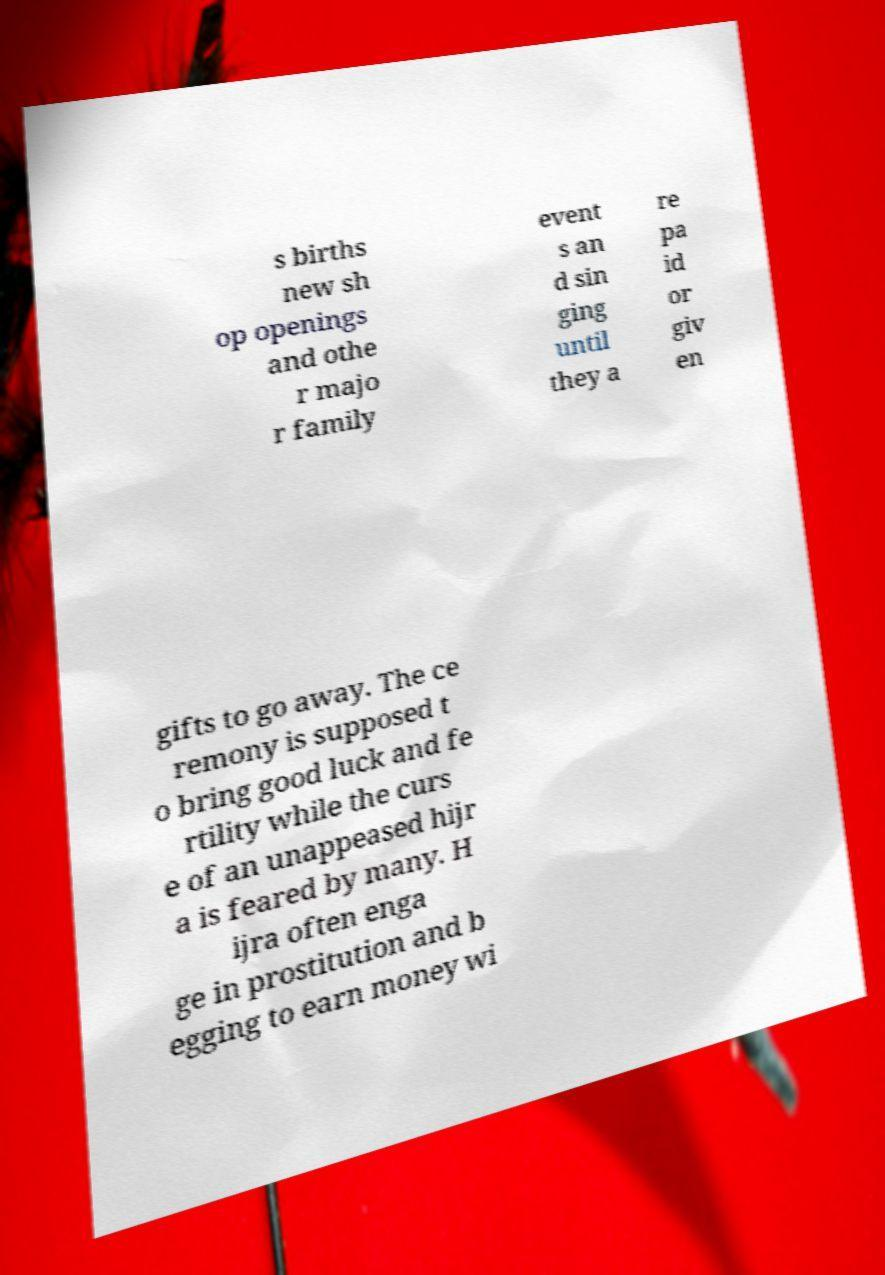Could you assist in decoding the text presented in this image and type it out clearly? s births new sh op openings and othe r majo r family event s an d sin ging until they a re pa id or giv en gifts to go away. The ce remony is supposed t o bring good luck and fe rtility while the curs e of an unappeased hijr a is feared by many. H ijra often enga ge in prostitution and b egging to earn money wi 